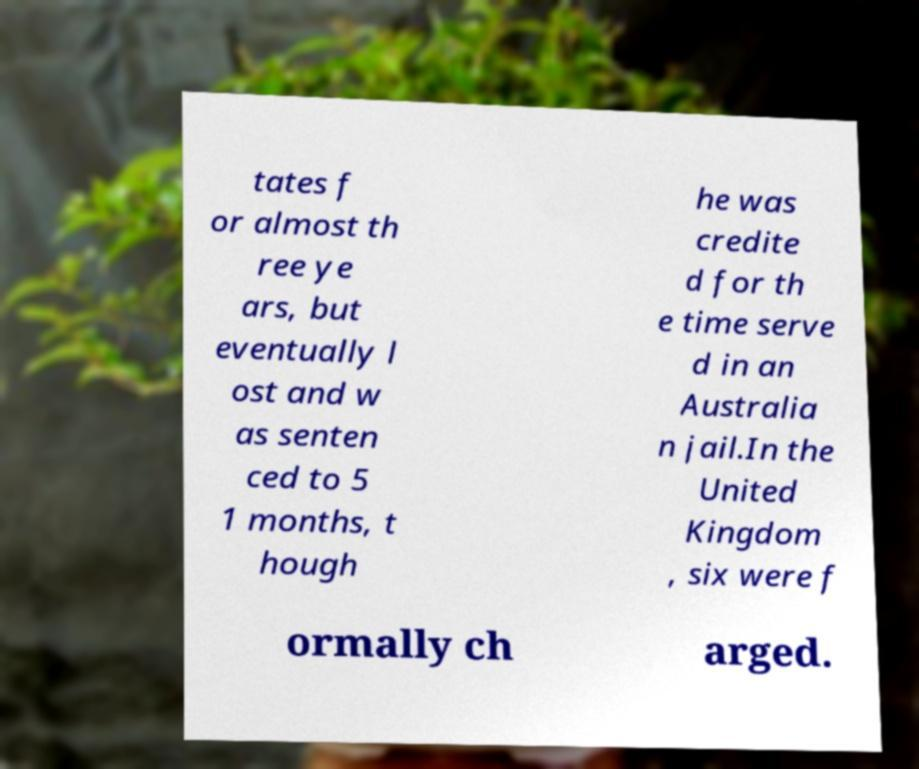Could you extract and type out the text from this image? tates f or almost th ree ye ars, but eventually l ost and w as senten ced to 5 1 months, t hough he was credite d for th e time serve d in an Australia n jail.In the United Kingdom , six were f ormally ch arged. 